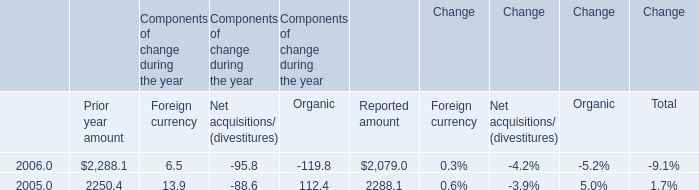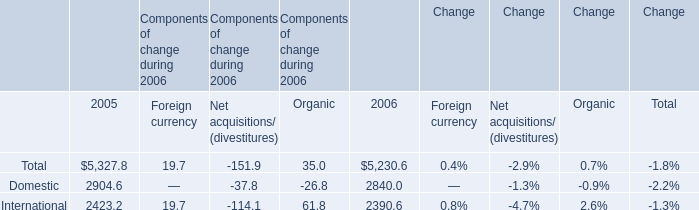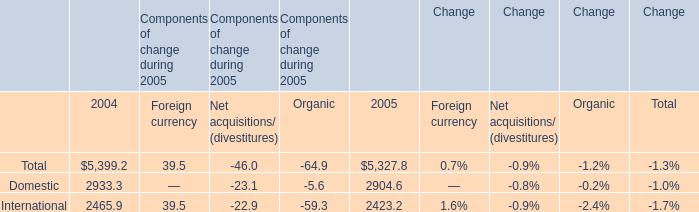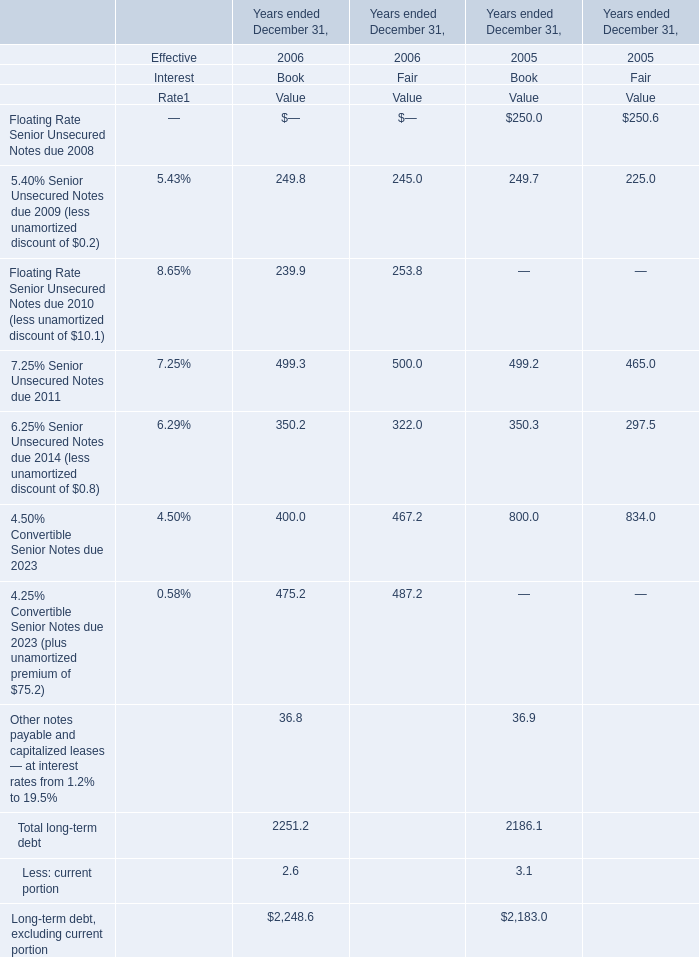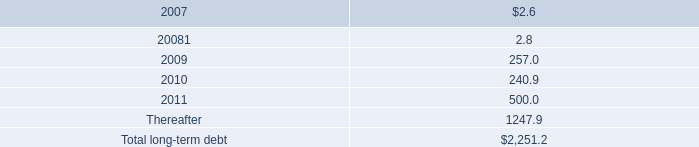If the Book Value of the long-term debt, excluding current portion develops with the same increasing rate as in 2006, what will it reach in 2007? 
Computations: (2248.6 * (1 + ((2248.6 - 2183) / 2183)))
Answer: 2316.17131. 